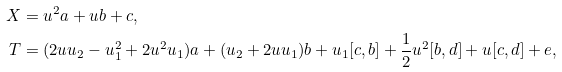<formula> <loc_0><loc_0><loc_500><loc_500>X & = u ^ { 2 } a + u b + c , \\ T & = ( 2 u u _ { 2 } - u _ { 1 } ^ { 2 } + 2 u ^ { 2 } u _ { 1 } ) a + ( u _ { 2 } + 2 u u _ { 1 } ) b + u _ { 1 } [ c , b ] + \frac { 1 } { 2 } u ^ { 2 } [ b , d ] + u [ c , d ] + e ,</formula> 